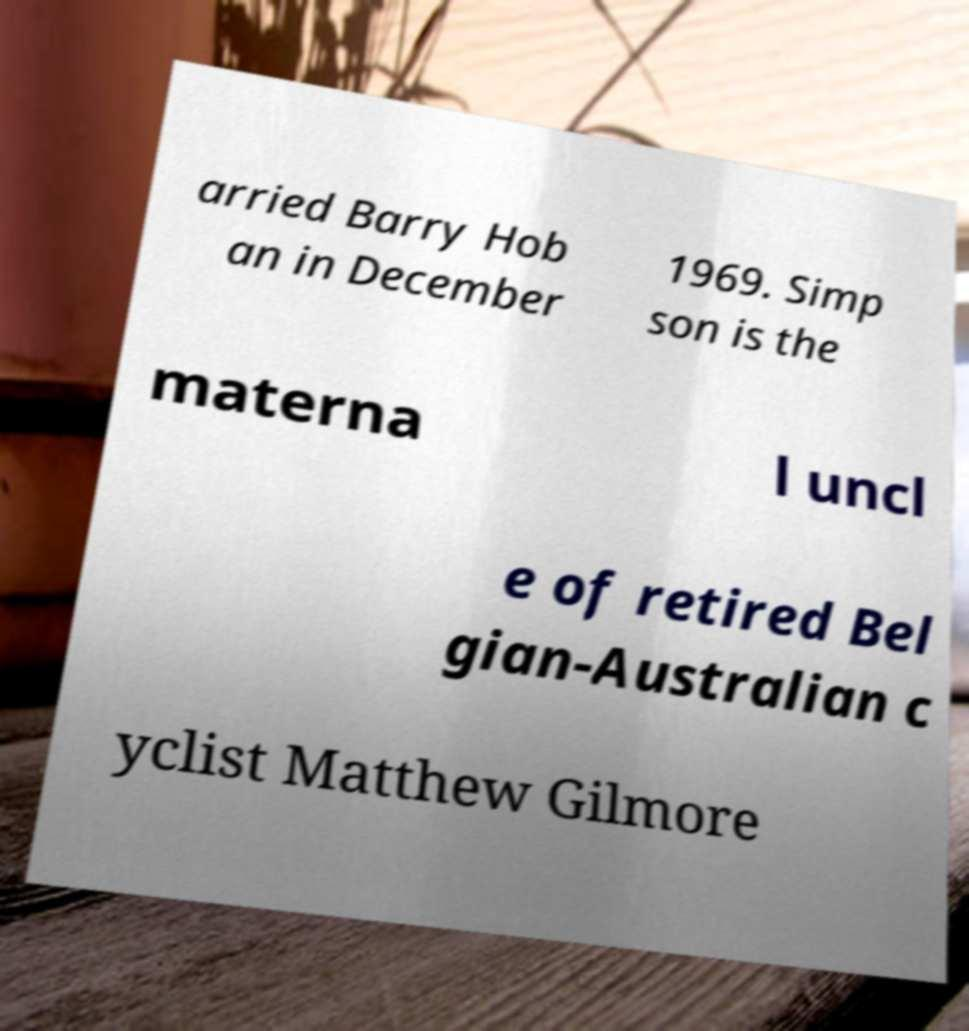For documentation purposes, I need the text within this image transcribed. Could you provide that? arried Barry Hob an in December 1969. Simp son is the materna l uncl e of retired Bel gian-Australian c yclist Matthew Gilmore 